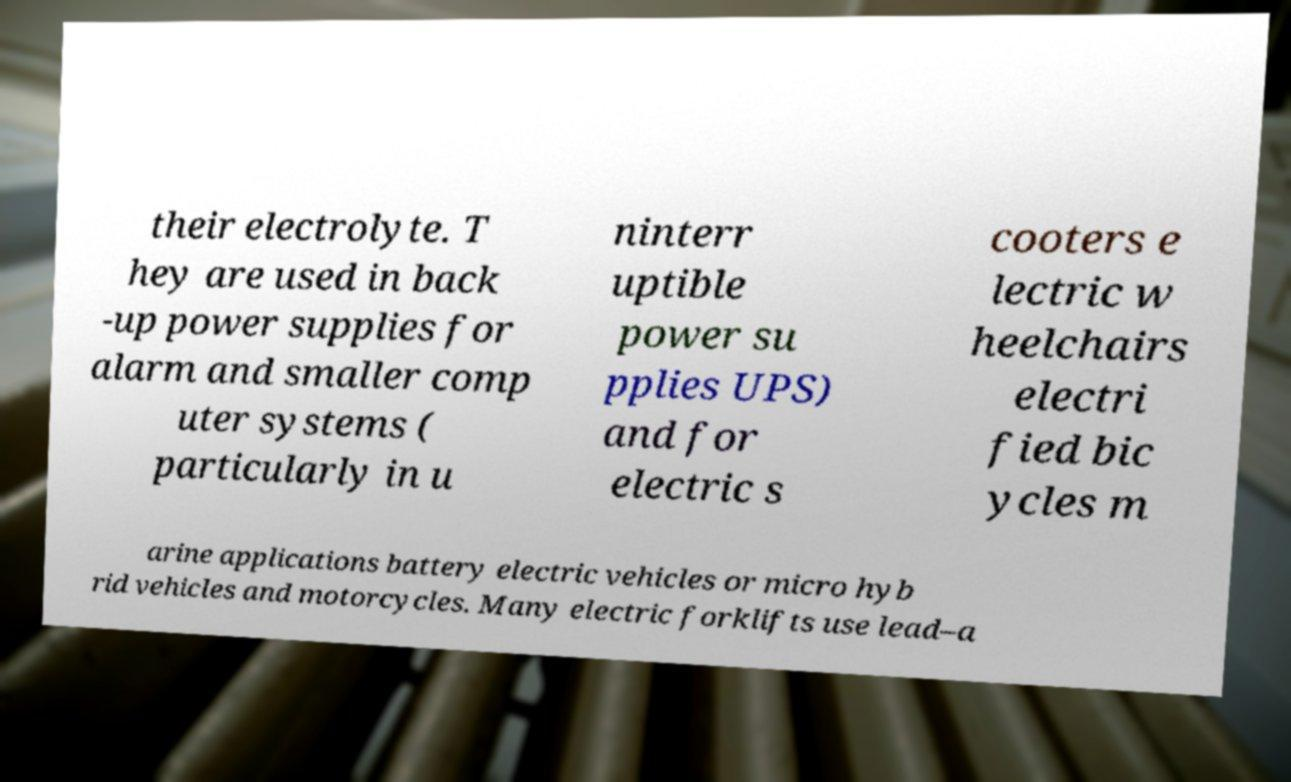Can you read and provide the text displayed in the image?This photo seems to have some interesting text. Can you extract and type it out for me? their electrolyte. T hey are used in back -up power supplies for alarm and smaller comp uter systems ( particularly in u ninterr uptible power su pplies UPS) and for electric s cooters e lectric w heelchairs electri fied bic ycles m arine applications battery electric vehicles or micro hyb rid vehicles and motorcycles. Many electric forklifts use lead–a 